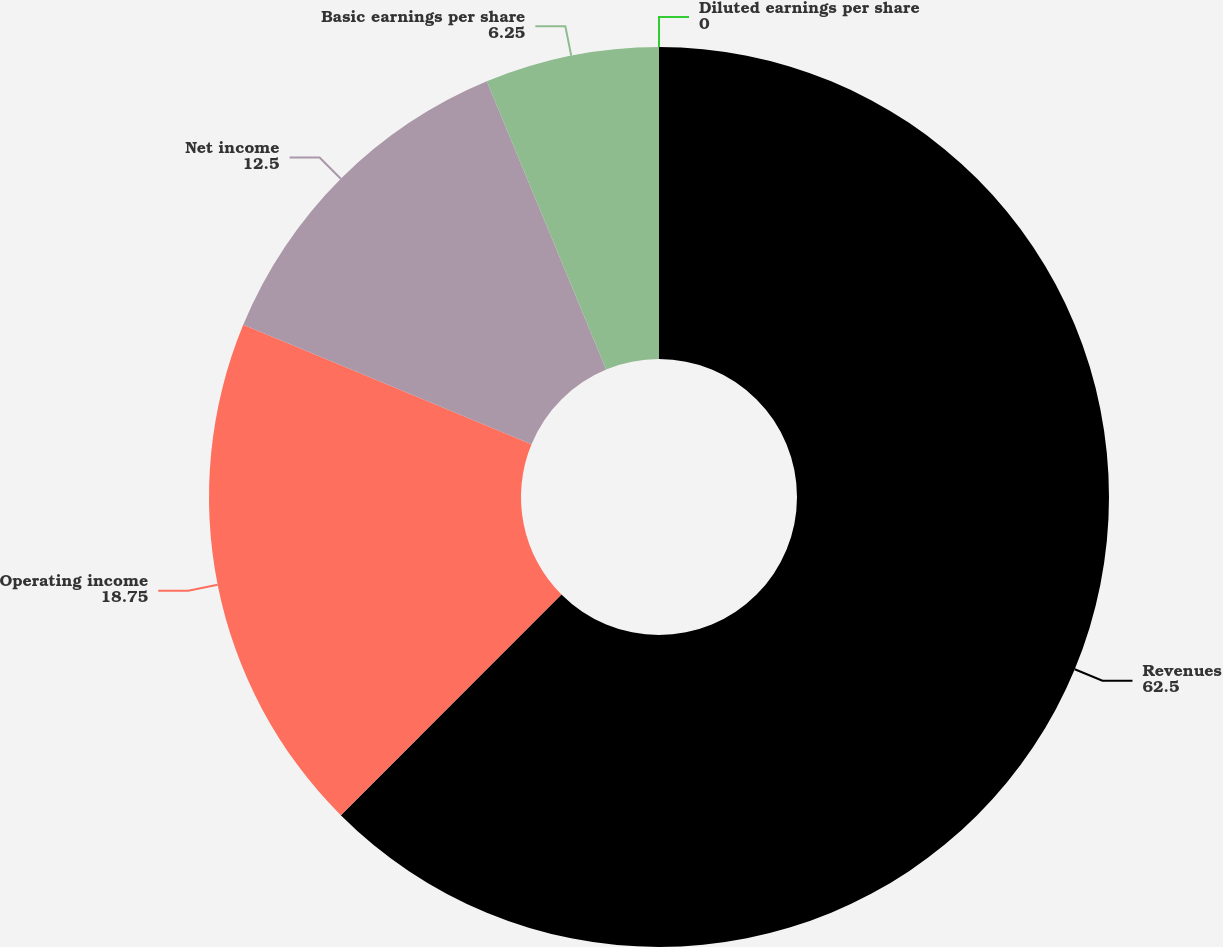Convert chart. <chart><loc_0><loc_0><loc_500><loc_500><pie_chart><fcel>Revenues<fcel>Operating income<fcel>Net income<fcel>Basic earnings per share<fcel>Diluted earnings per share<nl><fcel>62.5%<fcel>18.75%<fcel>12.5%<fcel>6.25%<fcel>0.0%<nl></chart> 